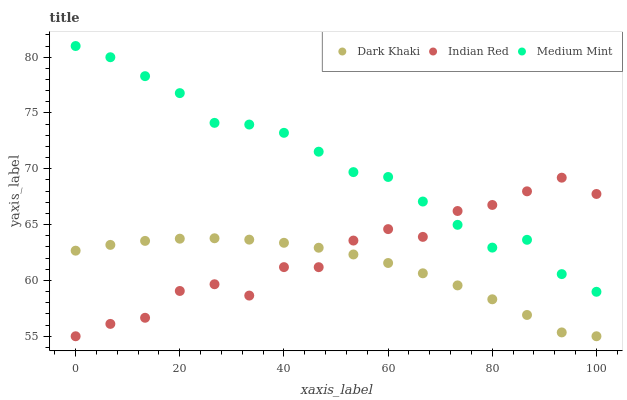Does Dark Khaki have the minimum area under the curve?
Answer yes or no. Yes. Does Medium Mint have the maximum area under the curve?
Answer yes or no. Yes. Does Indian Red have the minimum area under the curve?
Answer yes or no. No. Does Indian Red have the maximum area under the curve?
Answer yes or no. No. Is Dark Khaki the smoothest?
Answer yes or no. Yes. Is Indian Red the roughest?
Answer yes or no. Yes. Is Medium Mint the smoothest?
Answer yes or no. No. Is Medium Mint the roughest?
Answer yes or no. No. Does Dark Khaki have the lowest value?
Answer yes or no. Yes. Does Medium Mint have the lowest value?
Answer yes or no. No. Does Medium Mint have the highest value?
Answer yes or no. Yes. Does Indian Red have the highest value?
Answer yes or no. No. Is Dark Khaki less than Medium Mint?
Answer yes or no. Yes. Is Medium Mint greater than Dark Khaki?
Answer yes or no. Yes. Does Indian Red intersect Medium Mint?
Answer yes or no. Yes. Is Indian Red less than Medium Mint?
Answer yes or no. No. Is Indian Red greater than Medium Mint?
Answer yes or no. No. Does Dark Khaki intersect Medium Mint?
Answer yes or no. No. 